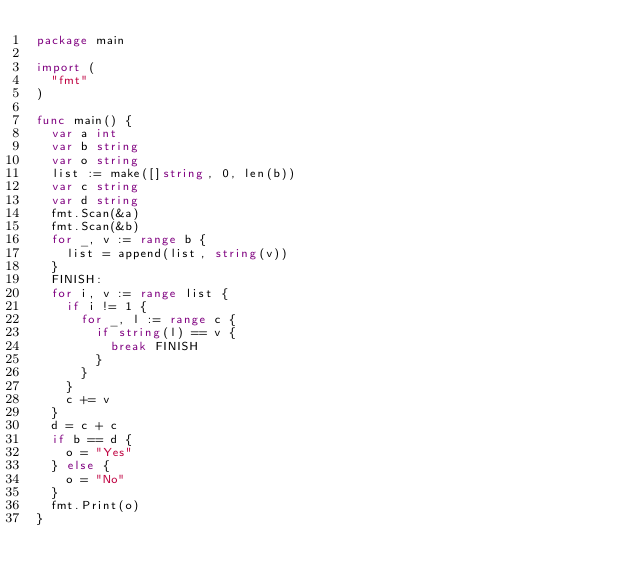Convert code to text. <code><loc_0><loc_0><loc_500><loc_500><_Go_>package main
 
import (
	"fmt"
)

func main() {
	var a int
	var b string
	var o string
	list := make([]string, 0, len(b))
	var c string
	var d string
	fmt.Scan(&a)
	fmt.Scan(&b)
	for _, v := range b {
		list = append(list, string(v))
	}
	FINISH:
	for i, v := range list {
		if i != 1 {
			for _, l := range c {
				if string(l) == v {
					break FINISH
				}
			}
		}
		c += v
	}
	d = c + c
	if b == d {
		o = "Yes"
	} else {
		o = "No"
	}
	fmt.Print(o)
}</code> 